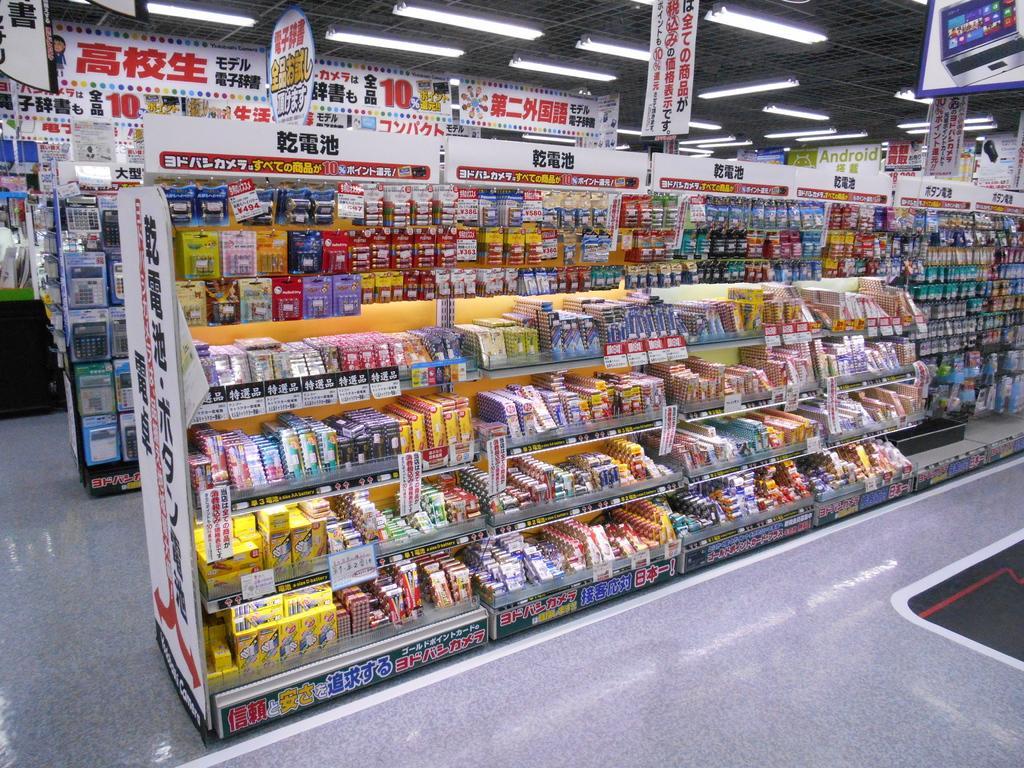Could you give a brief overview of what you see in this image? In this image there are items in the aisle in a supermarket. 